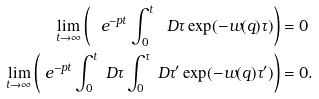<formula> <loc_0><loc_0><loc_500><loc_500>\lim _ { t \to \infty } \left ( \ e ^ { - p t } \int _ { 0 } ^ { t } \ D \tau \exp ( - w ( { q } ) \tau ) \right ) & = 0 \\ \lim _ { t \to \infty } \left ( \ e ^ { - p t } \int _ { 0 } ^ { t } \ D \tau \int _ { 0 } ^ { \tau } \ D \tau ^ { \prime } \exp ( - w ( { q } ) \tau ^ { \prime } ) \right ) & = 0 .</formula> 